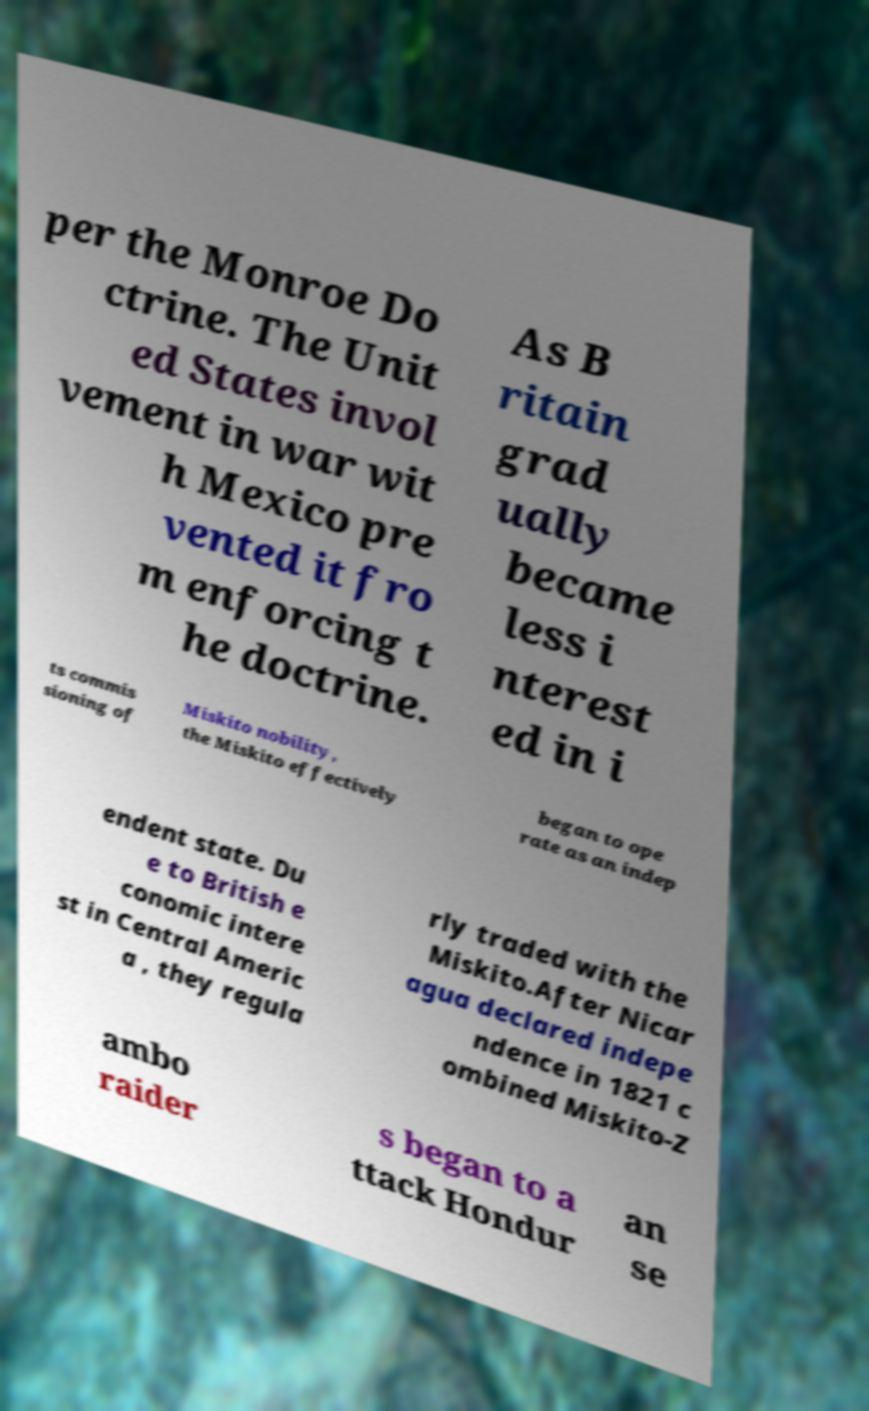There's text embedded in this image that I need extracted. Can you transcribe it verbatim? per the Monroe Do ctrine. The Unit ed States invol vement in war wit h Mexico pre vented it fro m enforcing t he doctrine. As B ritain grad ually became less i nterest ed in i ts commis sioning of Miskito nobility, the Miskito effectively began to ope rate as an indep endent state. Du e to British e conomic intere st in Central Americ a , they regula rly traded with the Miskito.After Nicar agua declared indepe ndence in 1821 c ombined Miskito-Z ambo raider s began to a ttack Hondur an se 